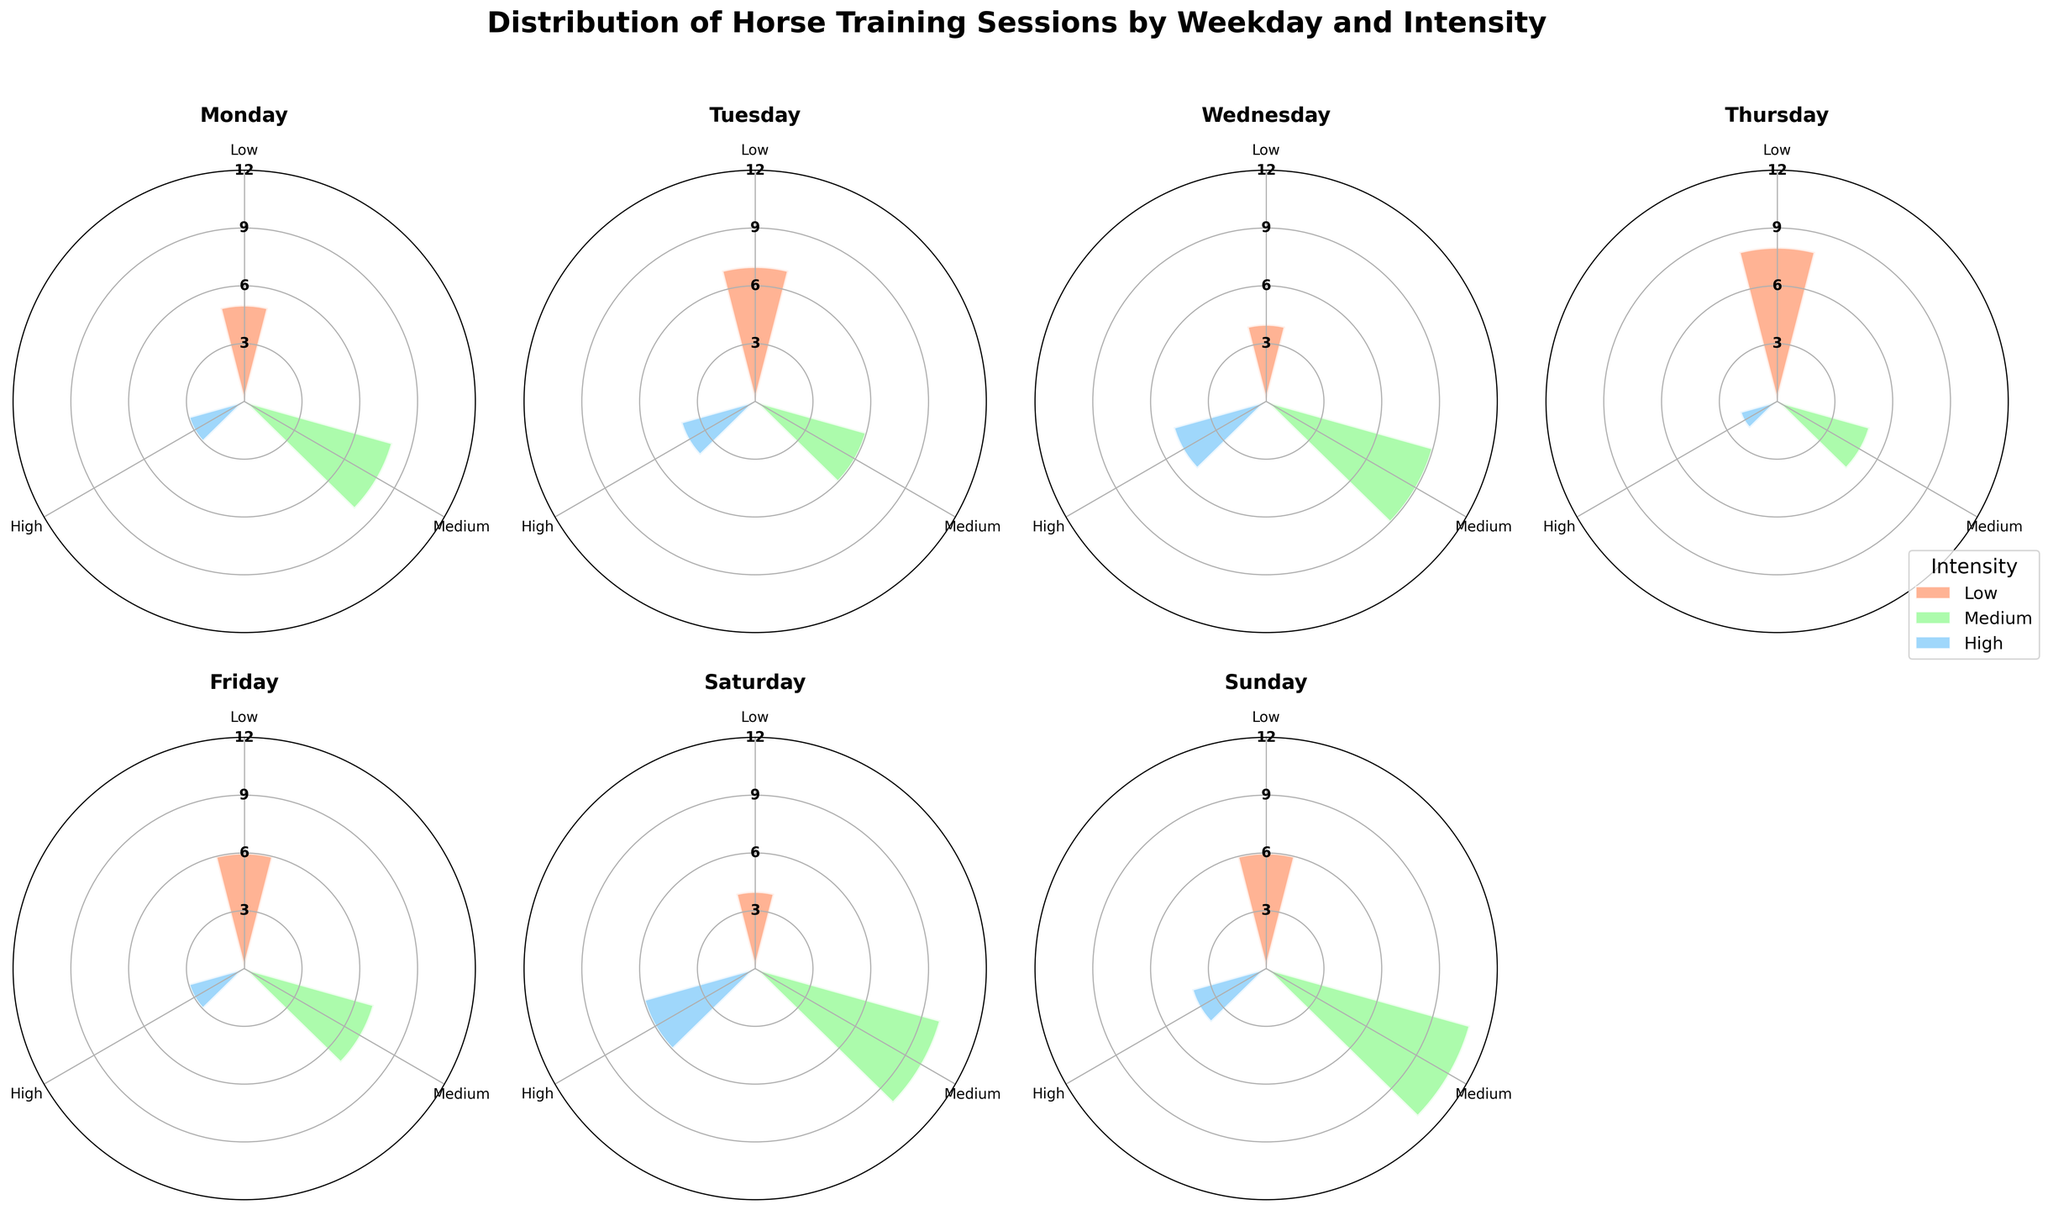What is the title of the figure? The figure title is found at the top and gives an overview of what the figure represents. The title in this case is clearly stated.
Answer: Distribution of Horse Training Sessions by Weekday and Intensity How many training sessions occurred on Monday with high intensity? Refer to the Monday section of the chart and look for the segment labeled as 'High' to determine the number of training sessions.
Answer: 3 Which weekday has the highest number of medium-intensity training sessions? Compare the medium-intensity segments across all weekdays to find the one with the highest count.
Answer: Sunday How many total training sessions occurred on Tuesday? Sum the training sessions of all intensities for Tuesday. 7 (Low) + 6 (Medium) + 4 (High)
Answer: 17 What is the average number of training sessions on Wednesday for all intensities? Sum the training sessions of all intensities for Wednesday and then divide by 3 (number of intensities). (4 + 9 + 5)/3
Answer: 6 Does Thursday have more high-intensity training sessions than Friday? Compare the high-intensity segments for Thursday and Friday.
Answer: No What is the most common intensity level for training sessions across all days? Identify the intensity level with the highest total count across all days by summing sessions for Low, Medium, and High intensities.
Answer: Medium Which weekday has the least number of low-intensity training sessions? Compare the low-intensity segments across all days to find the one with the lowest count.
Answer: Wednesday How many more medium-intensity sessions are there on Saturday compared to Monday? Subtract the number of medium-intensity sessions on Monday from those on Saturday. Saturday (10) - Monday (8)
Answer: 2 Is the distribution of training session intensities uniform across weekdays? Observe the variations in the length of the bars for each intensity across different weekdays to evaluate uniformity.
Answer: No 